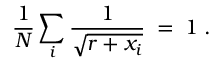Convert formula to latex. <formula><loc_0><loc_0><loc_500><loc_500>{ \frac { 1 } { N } } \sum _ { i } { \frac { 1 } { \sqrt { r + x _ { i } } } } \, = \, 1 \, .</formula> 